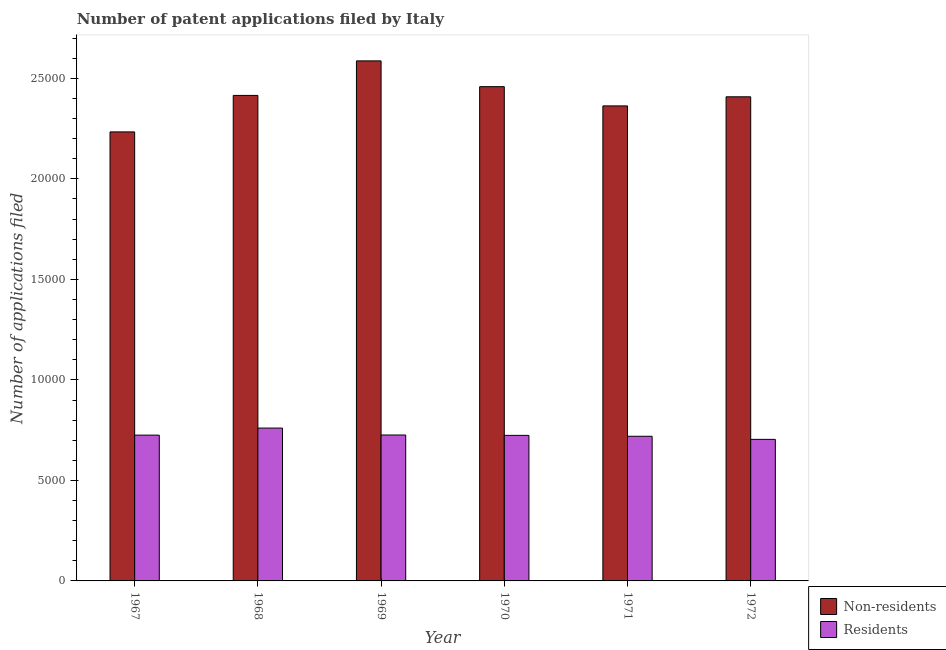How many different coloured bars are there?
Make the answer very short. 2. Are the number of bars on each tick of the X-axis equal?
Offer a terse response. Yes. How many bars are there on the 6th tick from the left?
Your answer should be compact. 2. What is the label of the 6th group of bars from the left?
Offer a terse response. 1972. In how many cases, is the number of bars for a given year not equal to the number of legend labels?
Your answer should be compact. 0. What is the number of patent applications by non residents in 1970?
Offer a very short reply. 2.46e+04. Across all years, what is the maximum number of patent applications by residents?
Offer a very short reply. 7604. Across all years, what is the minimum number of patent applications by residents?
Offer a very short reply. 7042. In which year was the number of patent applications by residents maximum?
Keep it short and to the point. 1968. In which year was the number of patent applications by non residents minimum?
Make the answer very short. 1967. What is the total number of patent applications by non residents in the graph?
Your answer should be very brief. 1.45e+05. What is the difference between the number of patent applications by non residents in 1968 and that in 1971?
Keep it short and to the point. 522. What is the difference between the number of patent applications by non residents in 1971 and the number of patent applications by residents in 1967?
Offer a terse response. 1293. What is the average number of patent applications by residents per year?
Ensure brevity in your answer.  7265.83. In how many years, is the number of patent applications by residents greater than 12000?
Keep it short and to the point. 0. What is the ratio of the number of patent applications by residents in 1967 to that in 1972?
Make the answer very short. 1.03. Is the number of patent applications by non residents in 1968 less than that in 1969?
Provide a short and direct response. Yes. Is the difference between the number of patent applications by residents in 1967 and 1971 greater than the difference between the number of patent applications by non residents in 1967 and 1971?
Your response must be concise. No. What is the difference between the highest and the second highest number of patent applications by non residents?
Offer a terse response. 1283. What is the difference between the highest and the lowest number of patent applications by non residents?
Your answer should be very brief. 3533. In how many years, is the number of patent applications by non residents greater than the average number of patent applications by non residents taken over all years?
Offer a very short reply. 3. What does the 1st bar from the left in 1968 represents?
Keep it short and to the point. Non-residents. What does the 1st bar from the right in 1968 represents?
Offer a very short reply. Residents. How many bars are there?
Offer a terse response. 12. Are all the bars in the graph horizontal?
Offer a very short reply. No. How many years are there in the graph?
Your response must be concise. 6. What is the difference between two consecutive major ticks on the Y-axis?
Provide a short and direct response. 5000. Does the graph contain grids?
Provide a succinct answer. No. What is the title of the graph?
Keep it short and to the point. Number of patent applications filed by Italy. Does "Under-5(female)" appear as one of the legend labels in the graph?
Ensure brevity in your answer.  No. What is the label or title of the Y-axis?
Your response must be concise. Number of applications filed. What is the Number of applications filed of Non-residents in 1967?
Provide a short and direct response. 2.23e+04. What is the Number of applications filed in Residents in 1967?
Provide a succinct answer. 7253. What is the Number of applications filed in Non-residents in 1968?
Your response must be concise. 2.42e+04. What is the Number of applications filed of Residents in 1968?
Keep it short and to the point. 7604. What is the Number of applications filed of Non-residents in 1969?
Your answer should be very brief. 2.59e+04. What is the Number of applications filed of Residents in 1969?
Make the answer very short. 7259. What is the Number of applications filed in Non-residents in 1970?
Provide a succinct answer. 2.46e+04. What is the Number of applications filed in Residents in 1970?
Make the answer very short. 7241. What is the Number of applications filed in Non-residents in 1971?
Your response must be concise. 2.36e+04. What is the Number of applications filed in Residents in 1971?
Your answer should be compact. 7196. What is the Number of applications filed of Non-residents in 1972?
Keep it short and to the point. 2.41e+04. What is the Number of applications filed in Residents in 1972?
Provide a succinct answer. 7042. Across all years, what is the maximum Number of applications filed in Non-residents?
Provide a succinct answer. 2.59e+04. Across all years, what is the maximum Number of applications filed in Residents?
Offer a terse response. 7604. Across all years, what is the minimum Number of applications filed of Non-residents?
Offer a terse response. 2.23e+04. Across all years, what is the minimum Number of applications filed of Residents?
Provide a succinct answer. 7042. What is the total Number of applications filed of Non-residents in the graph?
Offer a terse response. 1.45e+05. What is the total Number of applications filed in Residents in the graph?
Offer a terse response. 4.36e+04. What is the difference between the Number of applications filed in Non-residents in 1967 and that in 1968?
Ensure brevity in your answer.  -1815. What is the difference between the Number of applications filed of Residents in 1967 and that in 1968?
Offer a very short reply. -351. What is the difference between the Number of applications filed in Non-residents in 1967 and that in 1969?
Your answer should be very brief. -3533. What is the difference between the Number of applications filed of Non-residents in 1967 and that in 1970?
Provide a succinct answer. -2250. What is the difference between the Number of applications filed of Non-residents in 1967 and that in 1971?
Keep it short and to the point. -1293. What is the difference between the Number of applications filed in Residents in 1967 and that in 1971?
Your answer should be very brief. 57. What is the difference between the Number of applications filed of Non-residents in 1967 and that in 1972?
Your answer should be compact. -1746. What is the difference between the Number of applications filed in Residents in 1967 and that in 1972?
Provide a succinct answer. 211. What is the difference between the Number of applications filed in Non-residents in 1968 and that in 1969?
Offer a terse response. -1718. What is the difference between the Number of applications filed of Residents in 1968 and that in 1969?
Your answer should be compact. 345. What is the difference between the Number of applications filed of Non-residents in 1968 and that in 1970?
Make the answer very short. -435. What is the difference between the Number of applications filed of Residents in 1968 and that in 1970?
Offer a terse response. 363. What is the difference between the Number of applications filed in Non-residents in 1968 and that in 1971?
Provide a succinct answer. 522. What is the difference between the Number of applications filed in Residents in 1968 and that in 1971?
Ensure brevity in your answer.  408. What is the difference between the Number of applications filed of Non-residents in 1968 and that in 1972?
Your answer should be compact. 69. What is the difference between the Number of applications filed of Residents in 1968 and that in 1972?
Ensure brevity in your answer.  562. What is the difference between the Number of applications filed in Non-residents in 1969 and that in 1970?
Provide a short and direct response. 1283. What is the difference between the Number of applications filed in Residents in 1969 and that in 1970?
Keep it short and to the point. 18. What is the difference between the Number of applications filed in Non-residents in 1969 and that in 1971?
Give a very brief answer. 2240. What is the difference between the Number of applications filed in Residents in 1969 and that in 1971?
Offer a very short reply. 63. What is the difference between the Number of applications filed of Non-residents in 1969 and that in 1972?
Offer a terse response. 1787. What is the difference between the Number of applications filed in Residents in 1969 and that in 1972?
Ensure brevity in your answer.  217. What is the difference between the Number of applications filed of Non-residents in 1970 and that in 1971?
Your response must be concise. 957. What is the difference between the Number of applications filed in Non-residents in 1970 and that in 1972?
Make the answer very short. 504. What is the difference between the Number of applications filed in Residents in 1970 and that in 1972?
Provide a succinct answer. 199. What is the difference between the Number of applications filed of Non-residents in 1971 and that in 1972?
Keep it short and to the point. -453. What is the difference between the Number of applications filed of Residents in 1971 and that in 1972?
Give a very brief answer. 154. What is the difference between the Number of applications filed in Non-residents in 1967 and the Number of applications filed in Residents in 1968?
Give a very brief answer. 1.47e+04. What is the difference between the Number of applications filed in Non-residents in 1967 and the Number of applications filed in Residents in 1969?
Offer a very short reply. 1.51e+04. What is the difference between the Number of applications filed in Non-residents in 1967 and the Number of applications filed in Residents in 1970?
Keep it short and to the point. 1.51e+04. What is the difference between the Number of applications filed in Non-residents in 1967 and the Number of applications filed in Residents in 1971?
Give a very brief answer. 1.51e+04. What is the difference between the Number of applications filed of Non-residents in 1967 and the Number of applications filed of Residents in 1972?
Offer a terse response. 1.53e+04. What is the difference between the Number of applications filed in Non-residents in 1968 and the Number of applications filed in Residents in 1969?
Your response must be concise. 1.69e+04. What is the difference between the Number of applications filed of Non-residents in 1968 and the Number of applications filed of Residents in 1970?
Your response must be concise. 1.69e+04. What is the difference between the Number of applications filed of Non-residents in 1968 and the Number of applications filed of Residents in 1971?
Offer a very short reply. 1.70e+04. What is the difference between the Number of applications filed in Non-residents in 1968 and the Number of applications filed in Residents in 1972?
Keep it short and to the point. 1.71e+04. What is the difference between the Number of applications filed in Non-residents in 1969 and the Number of applications filed in Residents in 1970?
Make the answer very short. 1.86e+04. What is the difference between the Number of applications filed of Non-residents in 1969 and the Number of applications filed of Residents in 1971?
Make the answer very short. 1.87e+04. What is the difference between the Number of applications filed in Non-residents in 1969 and the Number of applications filed in Residents in 1972?
Ensure brevity in your answer.  1.88e+04. What is the difference between the Number of applications filed in Non-residents in 1970 and the Number of applications filed in Residents in 1971?
Offer a very short reply. 1.74e+04. What is the difference between the Number of applications filed in Non-residents in 1970 and the Number of applications filed in Residents in 1972?
Keep it short and to the point. 1.75e+04. What is the difference between the Number of applications filed in Non-residents in 1971 and the Number of applications filed in Residents in 1972?
Make the answer very short. 1.66e+04. What is the average Number of applications filed of Non-residents per year?
Keep it short and to the point. 2.41e+04. What is the average Number of applications filed of Residents per year?
Offer a terse response. 7265.83. In the year 1967, what is the difference between the Number of applications filed in Non-residents and Number of applications filed in Residents?
Provide a succinct answer. 1.51e+04. In the year 1968, what is the difference between the Number of applications filed in Non-residents and Number of applications filed in Residents?
Your answer should be very brief. 1.65e+04. In the year 1969, what is the difference between the Number of applications filed of Non-residents and Number of applications filed of Residents?
Make the answer very short. 1.86e+04. In the year 1970, what is the difference between the Number of applications filed of Non-residents and Number of applications filed of Residents?
Keep it short and to the point. 1.73e+04. In the year 1971, what is the difference between the Number of applications filed in Non-residents and Number of applications filed in Residents?
Your answer should be very brief. 1.64e+04. In the year 1972, what is the difference between the Number of applications filed of Non-residents and Number of applications filed of Residents?
Offer a terse response. 1.70e+04. What is the ratio of the Number of applications filed of Non-residents in 1967 to that in 1968?
Offer a very short reply. 0.92. What is the ratio of the Number of applications filed of Residents in 1967 to that in 1968?
Your answer should be compact. 0.95. What is the ratio of the Number of applications filed of Non-residents in 1967 to that in 1969?
Keep it short and to the point. 0.86. What is the ratio of the Number of applications filed in Residents in 1967 to that in 1969?
Your answer should be very brief. 1. What is the ratio of the Number of applications filed of Non-residents in 1967 to that in 1970?
Make the answer very short. 0.91. What is the ratio of the Number of applications filed in Non-residents in 1967 to that in 1971?
Your response must be concise. 0.95. What is the ratio of the Number of applications filed in Residents in 1967 to that in 1971?
Offer a terse response. 1.01. What is the ratio of the Number of applications filed in Non-residents in 1967 to that in 1972?
Keep it short and to the point. 0.93. What is the ratio of the Number of applications filed in Non-residents in 1968 to that in 1969?
Offer a very short reply. 0.93. What is the ratio of the Number of applications filed in Residents in 1968 to that in 1969?
Give a very brief answer. 1.05. What is the ratio of the Number of applications filed in Non-residents in 1968 to that in 1970?
Your answer should be very brief. 0.98. What is the ratio of the Number of applications filed in Residents in 1968 to that in 1970?
Provide a short and direct response. 1.05. What is the ratio of the Number of applications filed of Non-residents in 1968 to that in 1971?
Provide a short and direct response. 1.02. What is the ratio of the Number of applications filed of Residents in 1968 to that in 1971?
Provide a succinct answer. 1.06. What is the ratio of the Number of applications filed in Non-residents in 1968 to that in 1972?
Ensure brevity in your answer.  1. What is the ratio of the Number of applications filed of Residents in 1968 to that in 1972?
Offer a very short reply. 1.08. What is the ratio of the Number of applications filed in Non-residents in 1969 to that in 1970?
Offer a terse response. 1.05. What is the ratio of the Number of applications filed in Non-residents in 1969 to that in 1971?
Your response must be concise. 1.09. What is the ratio of the Number of applications filed of Residents in 1969 to that in 1971?
Offer a terse response. 1.01. What is the ratio of the Number of applications filed in Non-residents in 1969 to that in 1972?
Provide a succinct answer. 1.07. What is the ratio of the Number of applications filed in Residents in 1969 to that in 1972?
Make the answer very short. 1.03. What is the ratio of the Number of applications filed in Non-residents in 1970 to that in 1971?
Your response must be concise. 1.04. What is the ratio of the Number of applications filed of Residents in 1970 to that in 1971?
Make the answer very short. 1.01. What is the ratio of the Number of applications filed in Non-residents in 1970 to that in 1972?
Ensure brevity in your answer.  1.02. What is the ratio of the Number of applications filed in Residents in 1970 to that in 1972?
Your answer should be compact. 1.03. What is the ratio of the Number of applications filed in Non-residents in 1971 to that in 1972?
Make the answer very short. 0.98. What is the ratio of the Number of applications filed of Residents in 1971 to that in 1972?
Offer a terse response. 1.02. What is the difference between the highest and the second highest Number of applications filed in Non-residents?
Make the answer very short. 1283. What is the difference between the highest and the second highest Number of applications filed in Residents?
Provide a short and direct response. 345. What is the difference between the highest and the lowest Number of applications filed of Non-residents?
Provide a short and direct response. 3533. What is the difference between the highest and the lowest Number of applications filed in Residents?
Your answer should be very brief. 562. 